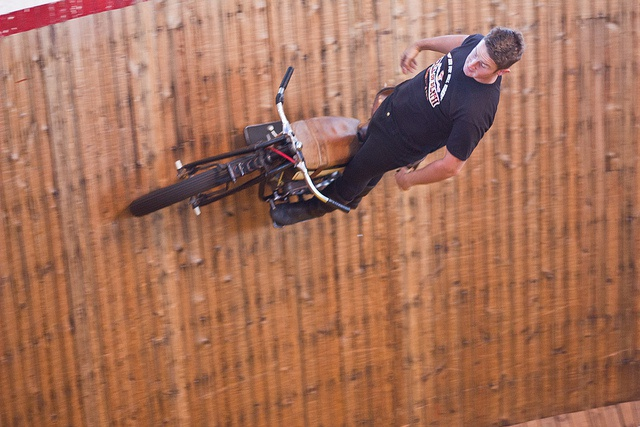Describe the objects in this image and their specific colors. I can see people in lavender, black, purple, and brown tones and bicycle in lavender, black, gray, maroon, and lightpink tones in this image. 